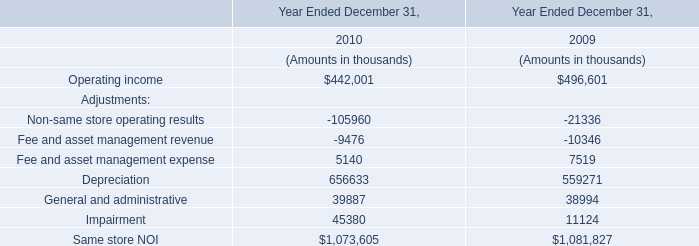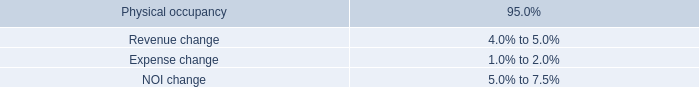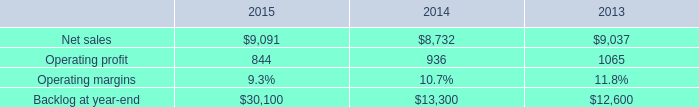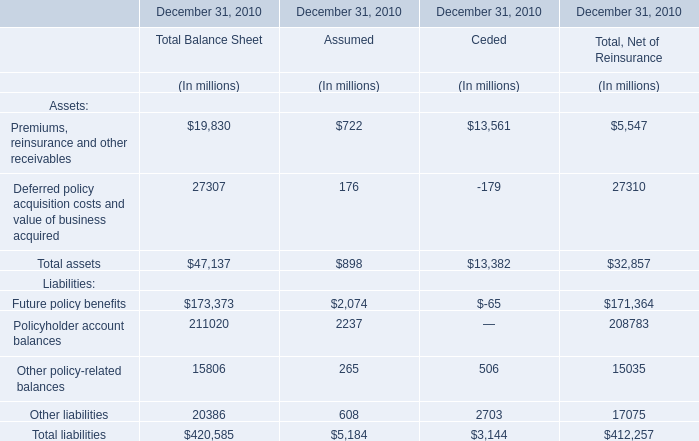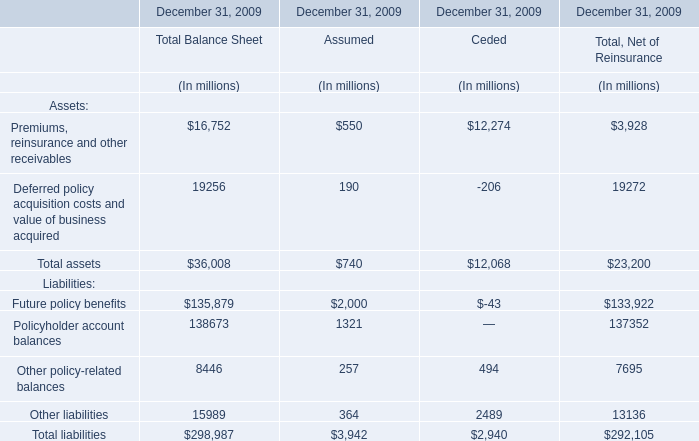What was the average value of Future policy benefits, Policyholder account balances, Other policy-related balances for Total Balance Sheet? (in million) 
Computations: (((173373 + 211020) + 15806) / 3)
Answer: 133399.66667. 